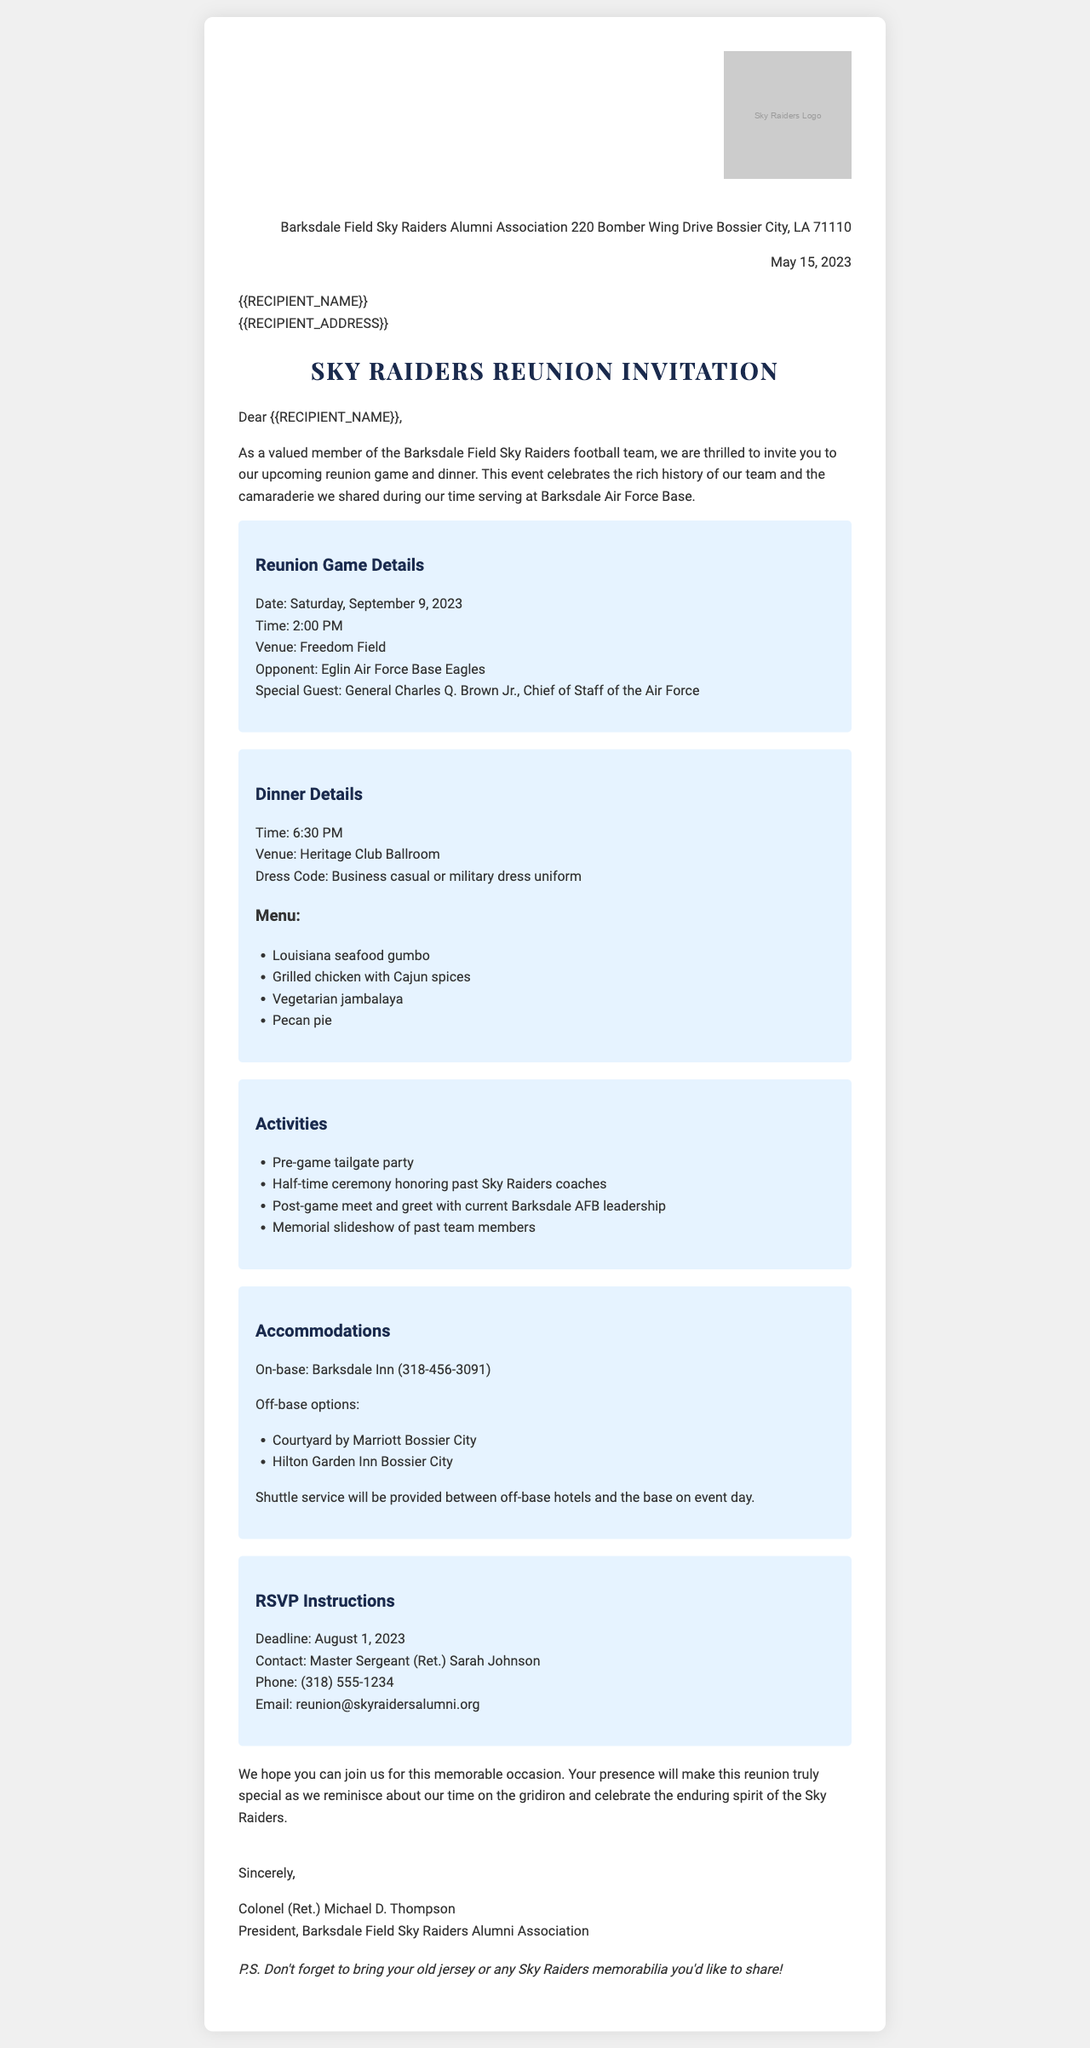What is the date of the reunion game? The date of the reunion game is specified in the introduction paragraph of the document.
Answer: Saturday, September 9, 2023 What is the venue for the dinner? The venue for the dinner is listed in the dinner details section of the document.
Answer: Heritage Club Ballroom Who is the special guest for the reunion game? The special guest is mentioned in the reunion game details section of the document.
Answer: General Charles Q. Brown Jr., Chief of Staff of the Air Force What is the dress code for the dinner? The dress code is provided in the dinner details section as part of the event information.
Answer: Business casual or military dress uniform What time does the reunion game start? The starting time for the reunion game is given in the reunion game details section.
Answer: 2:00 PM What activities are planned for the reunion? The activities planned for the reunion are listed in the activities section of the document.
Answer: Pre-game tailgate party, Half-time ceremony honoring past Sky Raiders coaches, Post-game meet and greet with current Barksdale AFB leadership, Memorial slideshow of past team members What is the RSVP deadline? The RSVP deadline is outlined in the RSVP instructions section of the document.
Answer: August 1, 2023 What is the contact email for RSVPs? The contact email for RSVPs is specified in the RSVP instructions section of the document.
Answer: reunion@skyraidersalumni.org Where can attendees find lodging options? Lodging options are mentioned in the accommodations section, providing both on-base and off-base hotels.
Answer: Barksdale Inn, Courtyard by Marriott Bossier City, Hilton Garden Inn Bossier City 